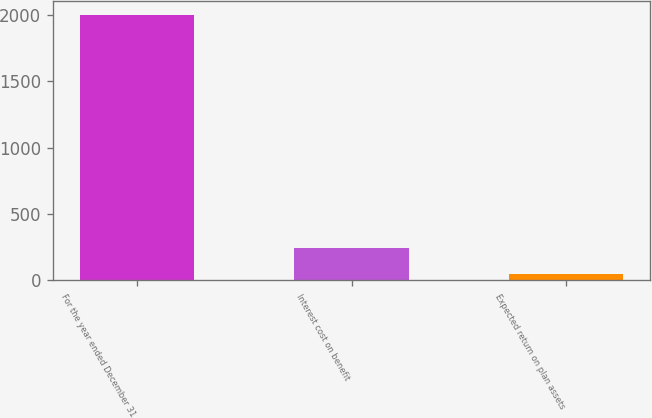<chart> <loc_0><loc_0><loc_500><loc_500><bar_chart><fcel>For the year ended December 31<fcel>Interest cost on benefit<fcel>Expected return on plan assets<nl><fcel>2001<fcel>243.3<fcel>48<nl></chart> 